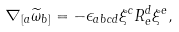Convert formula to latex. <formula><loc_0><loc_0><loc_500><loc_500>\nabla _ { [ a } \widetilde { \omega } _ { b ] } = - \epsilon _ { a b c d } \xi ^ { c } R _ { e } ^ { d } \xi ^ { e } ,</formula> 